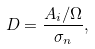<formula> <loc_0><loc_0><loc_500><loc_500>D = \frac { A _ { i } / \Omega } { \sigma _ { n } } ,</formula> 